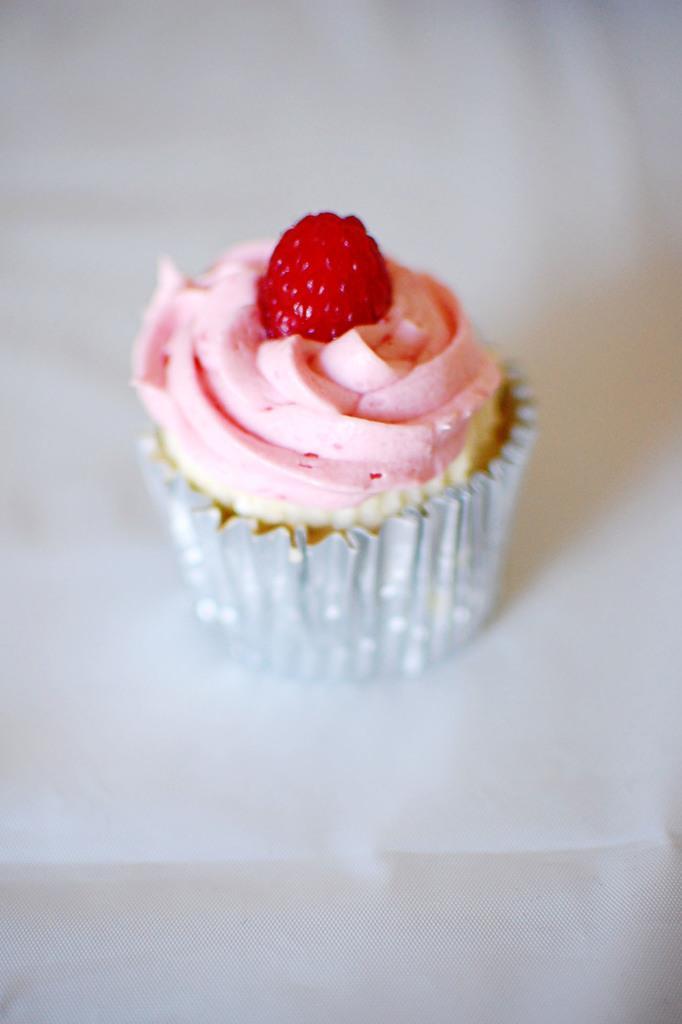How would you summarize this image in a sentence or two? In the center of the image, we can see a raspberry cupcake on the table. 